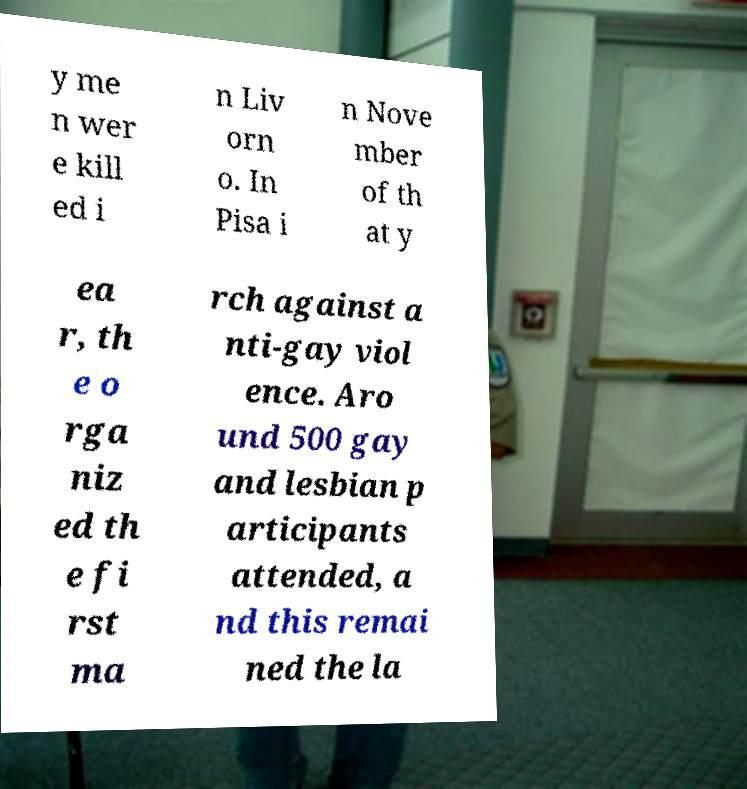Could you extract and type out the text from this image? y me n wer e kill ed i n Liv orn o. In Pisa i n Nove mber of th at y ea r, th e o rga niz ed th e fi rst ma rch against a nti-gay viol ence. Aro und 500 gay and lesbian p articipants attended, a nd this remai ned the la 